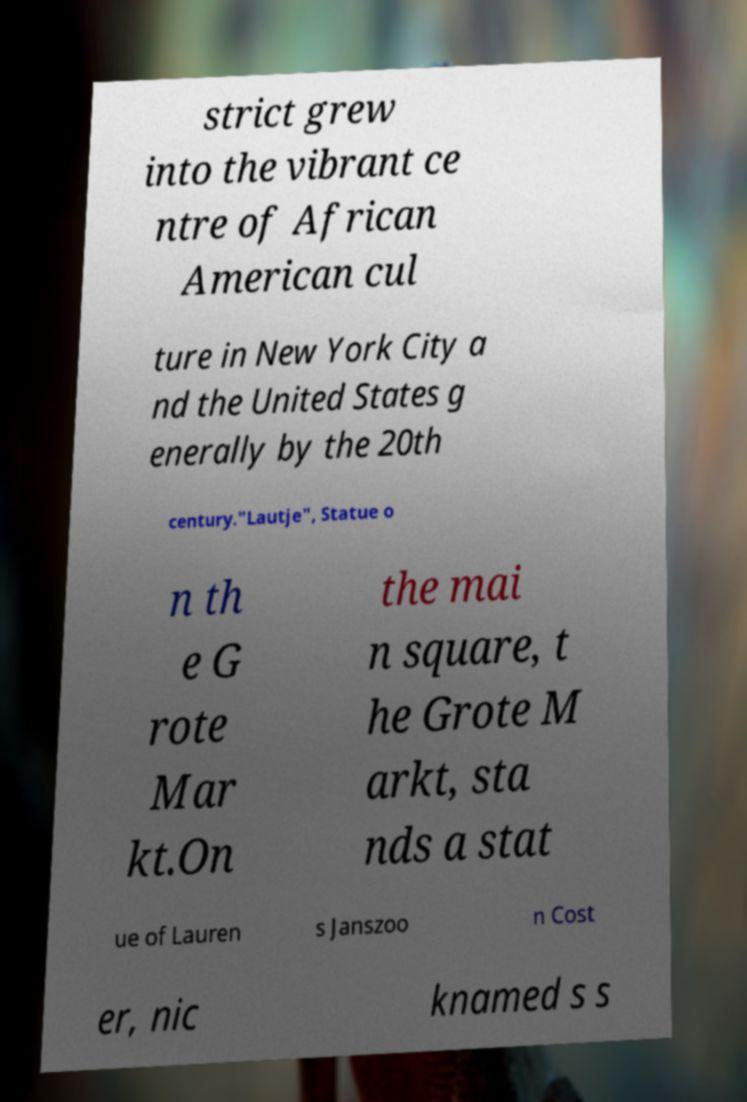Please read and relay the text visible in this image. What does it say? strict grew into the vibrant ce ntre of African American cul ture in New York City a nd the United States g enerally by the 20th century."Lautje", Statue o n th e G rote Mar kt.On the mai n square, t he Grote M arkt, sta nds a stat ue of Lauren s Janszoo n Cost er, nic knamed s s 